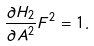<formula> <loc_0><loc_0><loc_500><loc_500>\frac { \partial H _ { 2 } } { \partial A ^ { 2 } } F ^ { 2 } = 1 .</formula> 